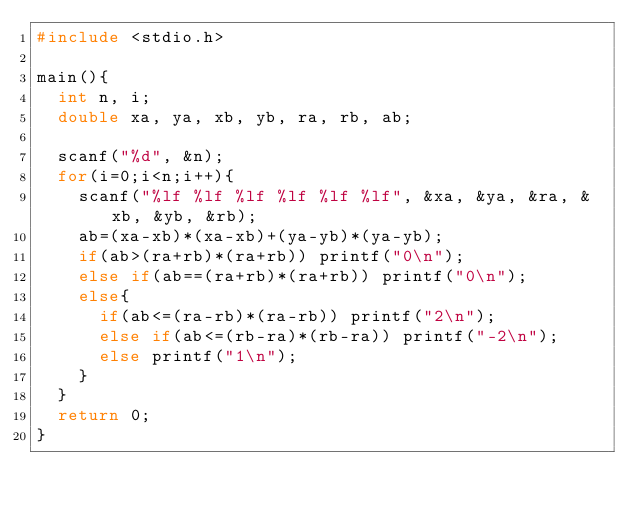<code> <loc_0><loc_0><loc_500><loc_500><_C_>#include <stdio.h>

main(){
  int n, i;
  double xa, ya, xb, yb, ra, rb, ab;

  scanf("%d", &n);
  for(i=0;i<n;i++){
    scanf("%lf %lf %lf %lf %lf %lf", &xa, &ya, &ra, &xb, &yb, &rb);
    ab=(xa-xb)*(xa-xb)+(ya-yb)*(ya-yb);
    if(ab>(ra+rb)*(ra+rb)) printf("0\n");
    else if(ab==(ra+rb)*(ra+rb)) printf("0\n");
    else{
      if(ab<=(ra-rb)*(ra-rb)) printf("2\n");
      else if(ab<=(rb-ra)*(rb-ra)) printf("-2\n");
      else printf("1\n");
    }
  }
  return 0;
}</code> 